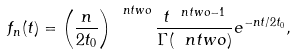<formula> <loc_0><loc_0><loc_500><loc_500>f _ { n } ( t ) = \left ( \frac { n } { 2 t _ { 0 } } \right ) ^ { \ n t w o } \frac { t ^ { \ n t w o - 1 } } { \Gamma ( \ n t w o ) } e ^ { - n t / 2 t _ { 0 } } ,</formula> 